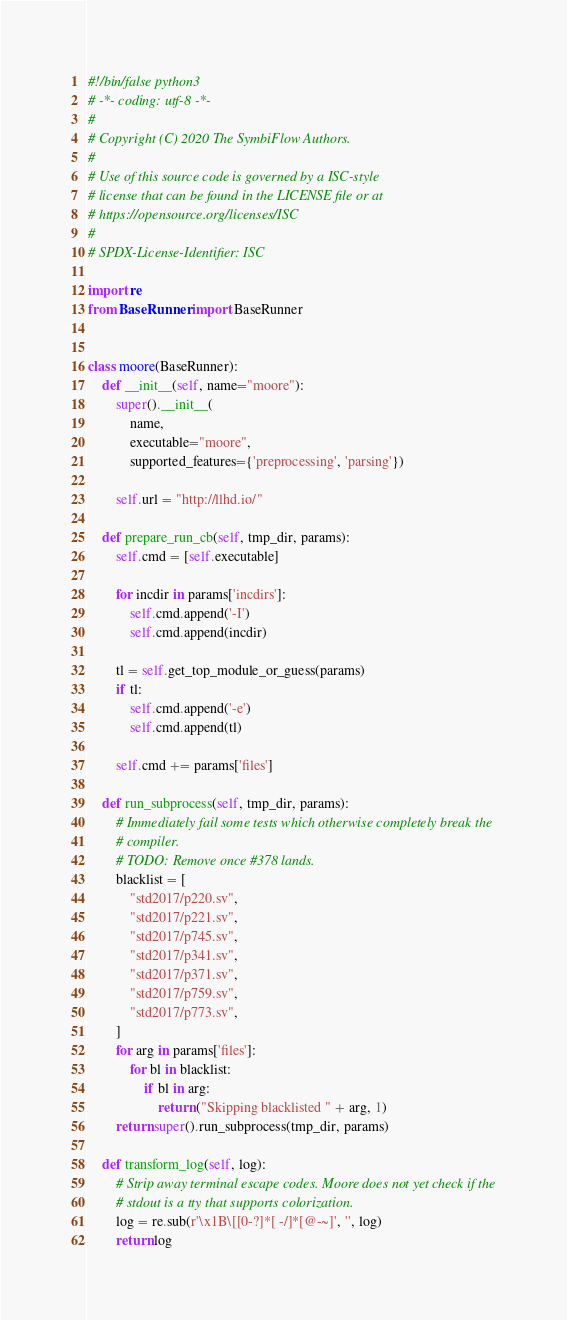Convert code to text. <code><loc_0><loc_0><loc_500><loc_500><_Python_>#!/bin/false python3
# -*- coding: utf-8 -*-
#
# Copyright (C) 2020 The SymbiFlow Authors.
#
# Use of this source code is governed by a ISC-style
# license that can be found in the LICENSE file or at
# https://opensource.org/licenses/ISC
#
# SPDX-License-Identifier: ISC

import re
from BaseRunner import BaseRunner


class moore(BaseRunner):
    def __init__(self, name="moore"):
        super().__init__(
            name,
            executable="moore",
            supported_features={'preprocessing', 'parsing'})

        self.url = "http://llhd.io/"

    def prepare_run_cb(self, tmp_dir, params):
        self.cmd = [self.executable]

        for incdir in params['incdirs']:
            self.cmd.append('-I')
            self.cmd.append(incdir)

        tl = self.get_top_module_or_guess(params)
        if tl:
            self.cmd.append('-e')
            self.cmd.append(tl)

        self.cmd += params['files']

    def run_subprocess(self, tmp_dir, params):
        # Immediately fail some tests which otherwise completely break the
        # compiler.
        # TODO: Remove once #378 lands.
        blacklist = [
            "std2017/p220.sv",
            "std2017/p221.sv",
            "std2017/p745.sv",
            "std2017/p341.sv",
            "std2017/p371.sv",
            "std2017/p759.sv",
            "std2017/p773.sv",
        ]
        for arg in params['files']:
            for bl in blacklist:
                if bl in arg:
                    return ("Skipping blacklisted " + arg, 1)
        return super().run_subprocess(tmp_dir, params)

    def transform_log(self, log):
        # Strip away terminal escape codes. Moore does not yet check if the
        # stdout is a tty that supports colorization.
        log = re.sub(r'\x1B\[[0-?]*[ -/]*[@-~]', '', log)
        return log
</code> 